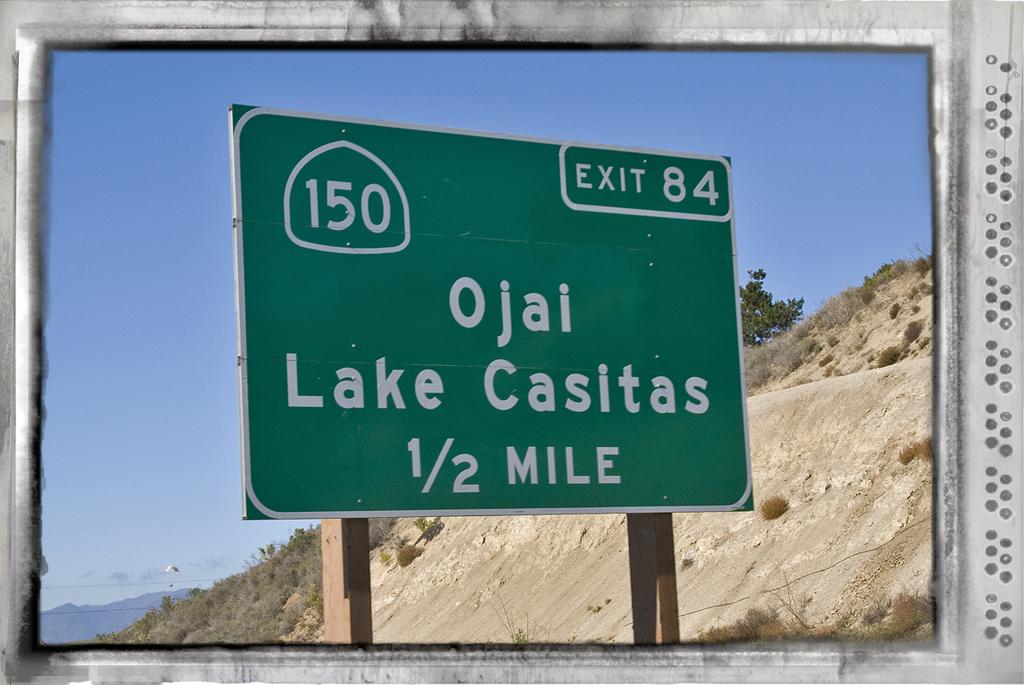What exit goes to ojai?
Make the answer very short. 84. How far is it to the ojai exit?
Provide a succinct answer. 1/2 mile. 